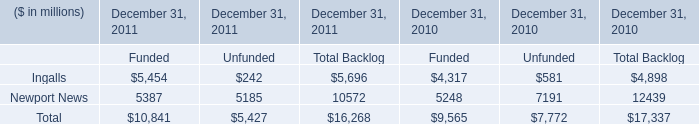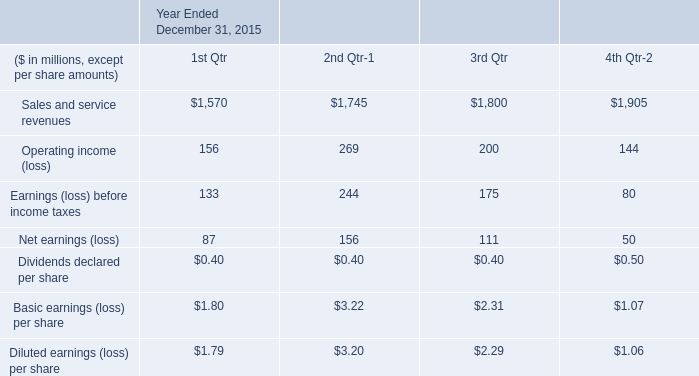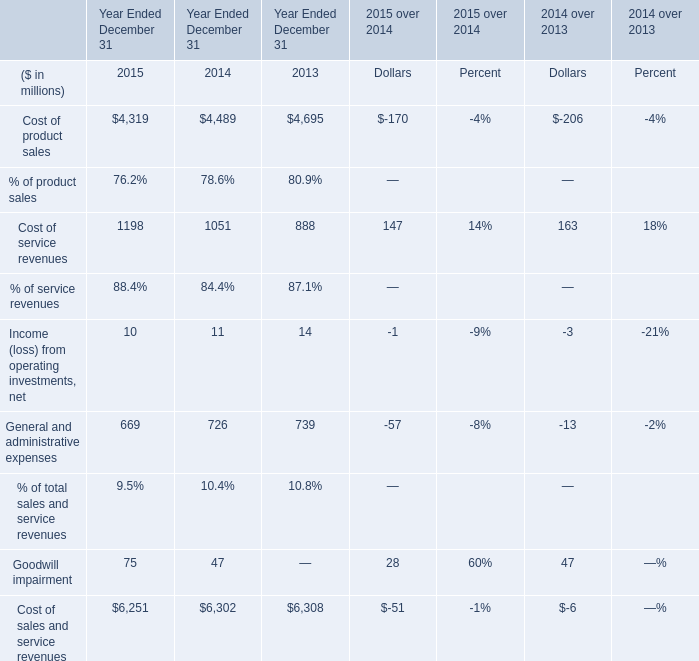between 2015 and 2013 what was the average compensation expense related to the issuing of the stock award in millions 
Computations: (((43 + 34) + 44) / 3)
Answer: 40.33333. In the yearwith the most Cost of service revenues, what is the growth rate of Income (loss) from operating investments, net? 
Computations: ((10 - 11) / 10)
Answer: -0.1. 